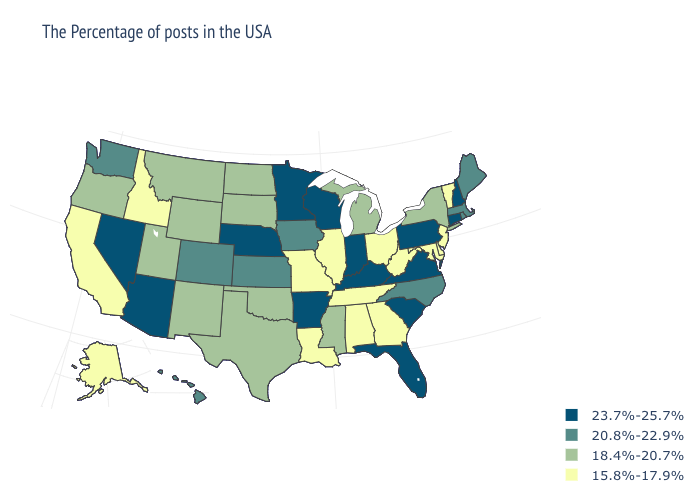What is the lowest value in the USA?
Keep it brief. 15.8%-17.9%. What is the highest value in the USA?
Answer briefly. 23.7%-25.7%. What is the value of North Dakota?
Keep it brief. 18.4%-20.7%. What is the lowest value in the Northeast?
Keep it brief. 15.8%-17.9%. What is the highest value in states that border Wyoming?
Keep it brief. 23.7%-25.7%. What is the value of South Carolina?
Write a very short answer. 23.7%-25.7%. Does Wyoming have the lowest value in the USA?
Quick response, please. No. What is the lowest value in the MidWest?
Keep it brief. 15.8%-17.9%. Which states have the lowest value in the USA?
Quick response, please. Vermont, New Jersey, Delaware, Maryland, West Virginia, Ohio, Georgia, Alabama, Tennessee, Illinois, Louisiana, Missouri, Idaho, California, Alaska. Among the states that border Ohio , which have the highest value?
Be succinct. Pennsylvania, Kentucky, Indiana. Name the states that have a value in the range 23.7%-25.7%?
Write a very short answer. New Hampshire, Connecticut, Pennsylvania, Virginia, South Carolina, Florida, Kentucky, Indiana, Wisconsin, Arkansas, Minnesota, Nebraska, Arizona, Nevada. Name the states that have a value in the range 20.8%-22.9%?
Concise answer only. Maine, Massachusetts, Rhode Island, North Carolina, Iowa, Kansas, Colorado, Washington, Hawaii. Name the states that have a value in the range 20.8%-22.9%?
Short answer required. Maine, Massachusetts, Rhode Island, North Carolina, Iowa, Kansas, Colorado, Washington, Hawaii. Name the states that have a value in the range 23.7%-25.7%?
Short answer required. New Hampshire, Connecticut, Pennsylvania, Virginia, South Carolina, Florida, Kentucky, Indiana, Wisconsin, Arkansas, Minnesota, Nebraska, Arizona, Nevada. What is the value of South Carolina?
Give a very brief answer. 23.7%-25.7%. 